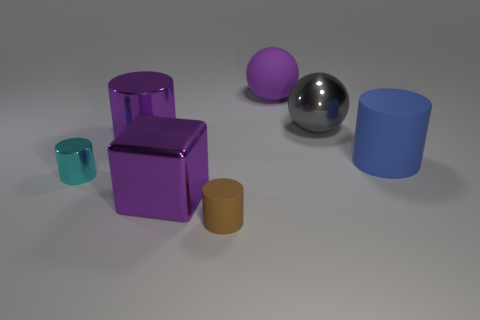There is a tiny object that is the same material as the gray ball; what is its shape?
Make the answer very short. Cylinder. Is there any other thing that has the same shape as the blue rubber thing?
Provide a short and direct response. Yes. What is the color of the matte object that is both behind the small cyan shiny cylinder and in front of the rubber ball?
Make the answer very short. Blue. How many cylinders are either gray things or purple shiny objects?
Your answer should be very brief. 1. What number of blue objects are the same size as the metal sphere?
Provide a short and direct response. 1. How many small matte cylinders are left of the purple metallic object that is in front of the big blue cylinder?
Ensure brevity in your answer.  0. There is a object that is right of the purple matte object and in front of the big gray thing; what size is it?
Offer a terse response. Large. Are there more matte balls than gray rubber cubes?
Offer a very short reply. Yes. Is there a shiny object that has the same color as the block?
Offer a terse response. Yes. Do the purple thing left of the block and the small cyan metal object have the same size?
Your response must be concise. No. 